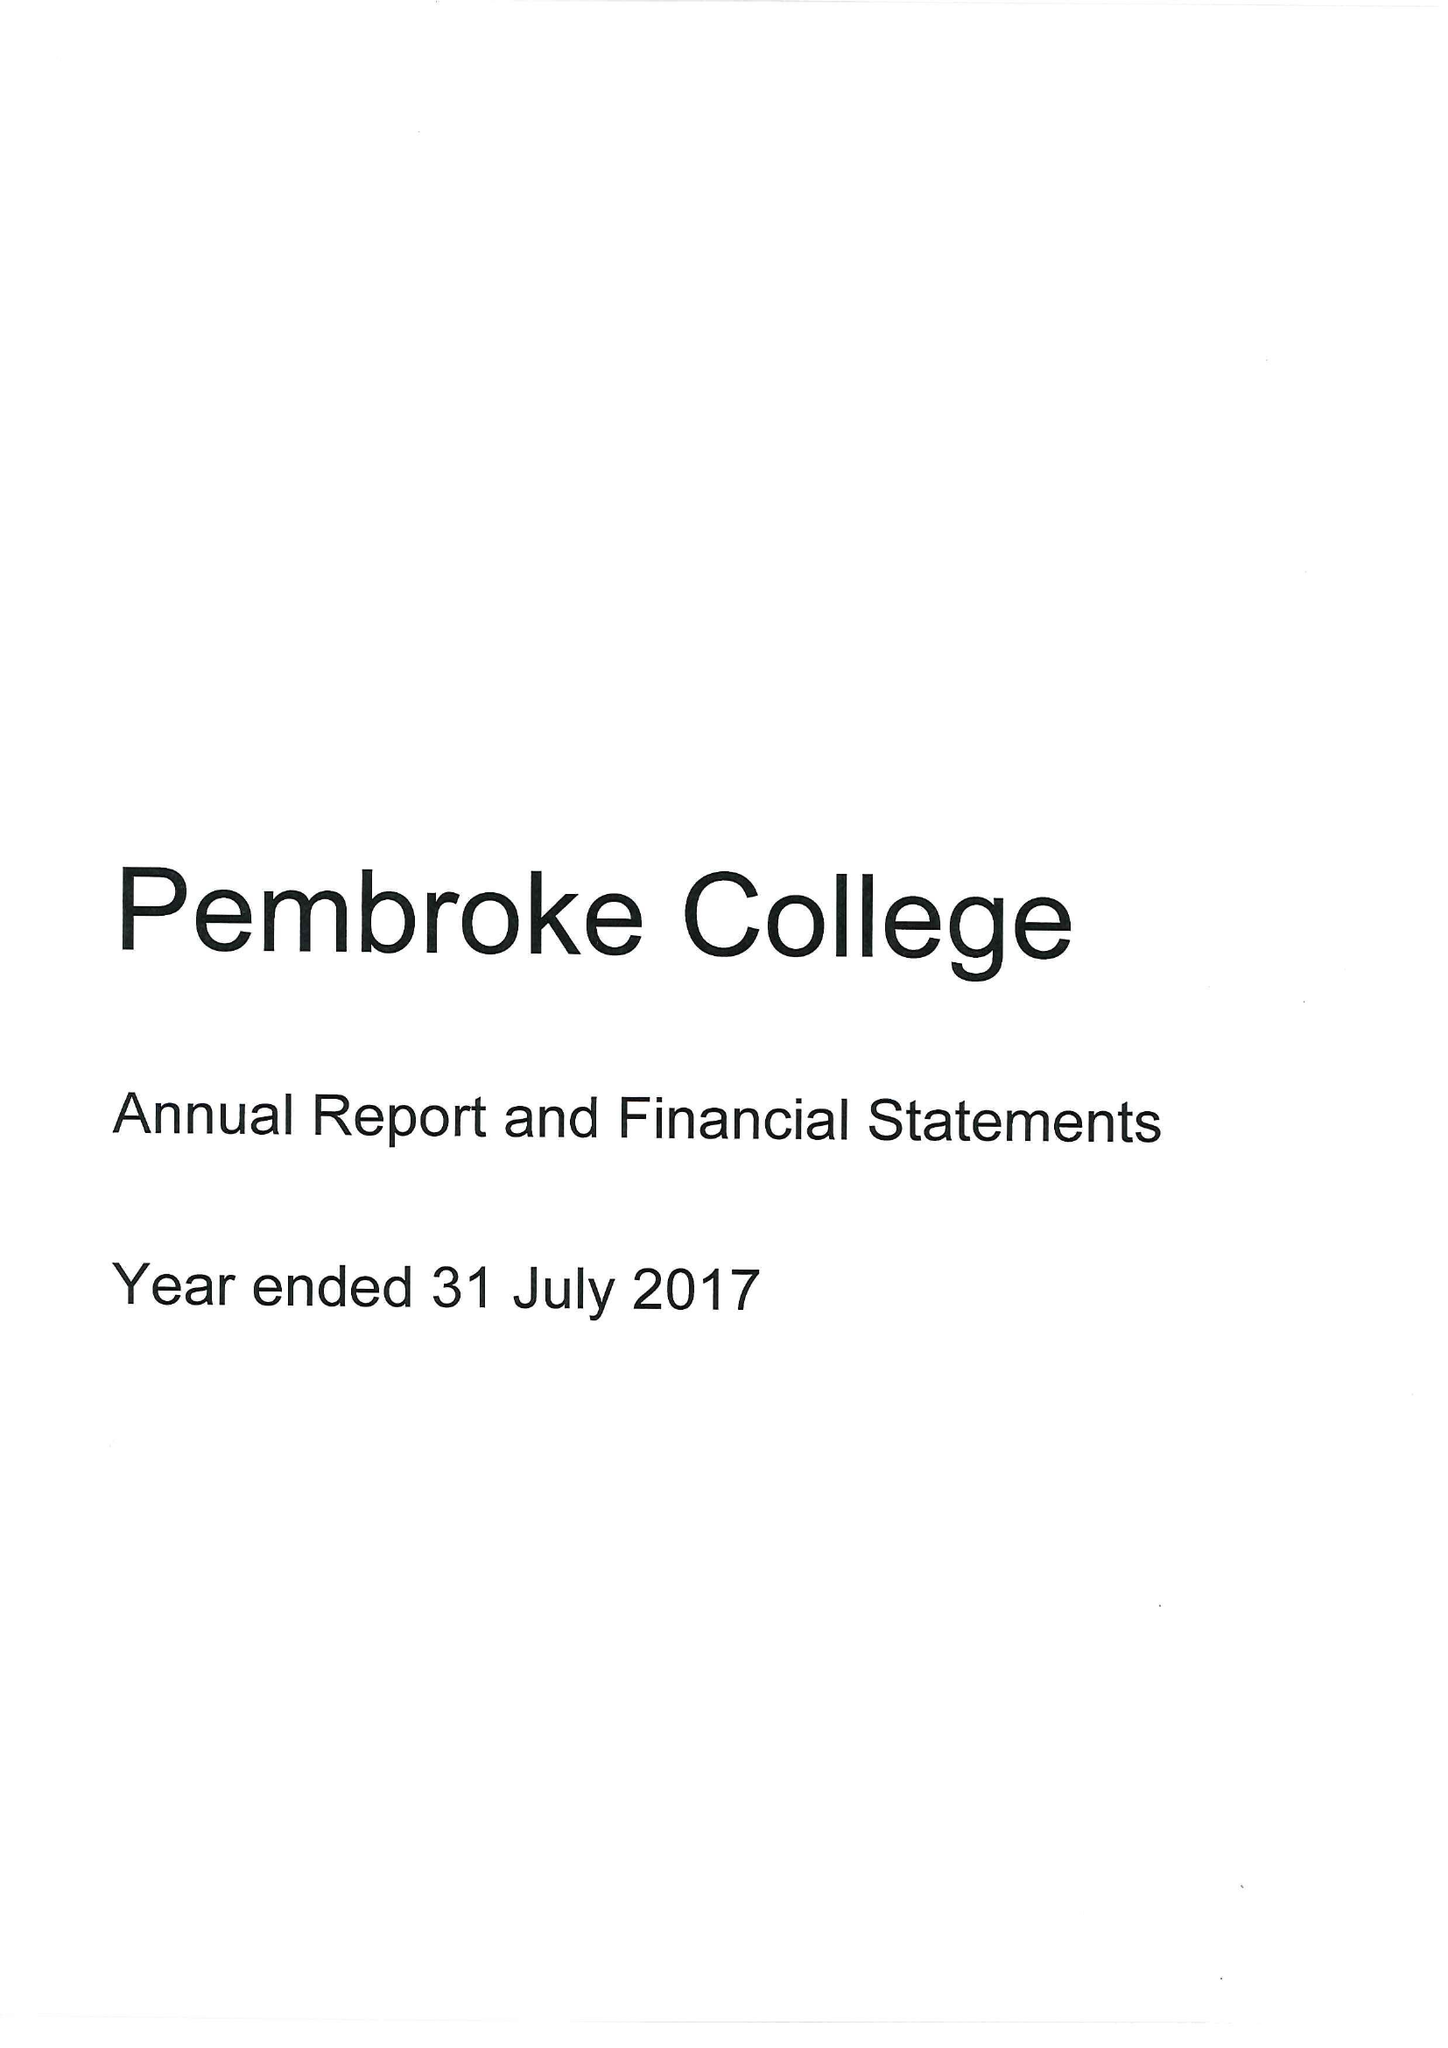What is the value for the income_annually_in_british_pounds?
Answer the question using a single word or phrase. 11727000.00 